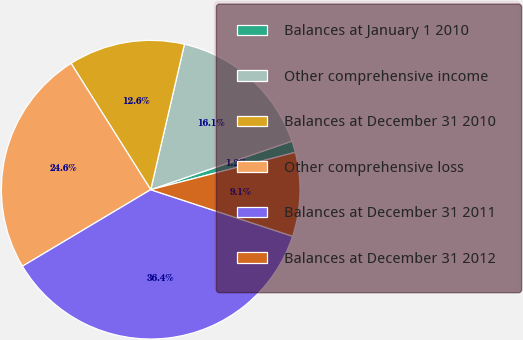Convert chart. <chart><loc_0><loc_0><loc_500><loc_500><pie_chart><fcel>Balances at January 1 2010<fcel>Other comprehensive income<fcel>Balances at December 31 2010<fcel>Other comprehensive loss<fcel>Balances at December 31 2011<fcel>Balances at December 31 2012<nl><fcel>1.25%<fcel>16.1%<fcel>12.58%<fcel>24.61%<fcel>36.39%<fcel>9.07%<nl></chart> 